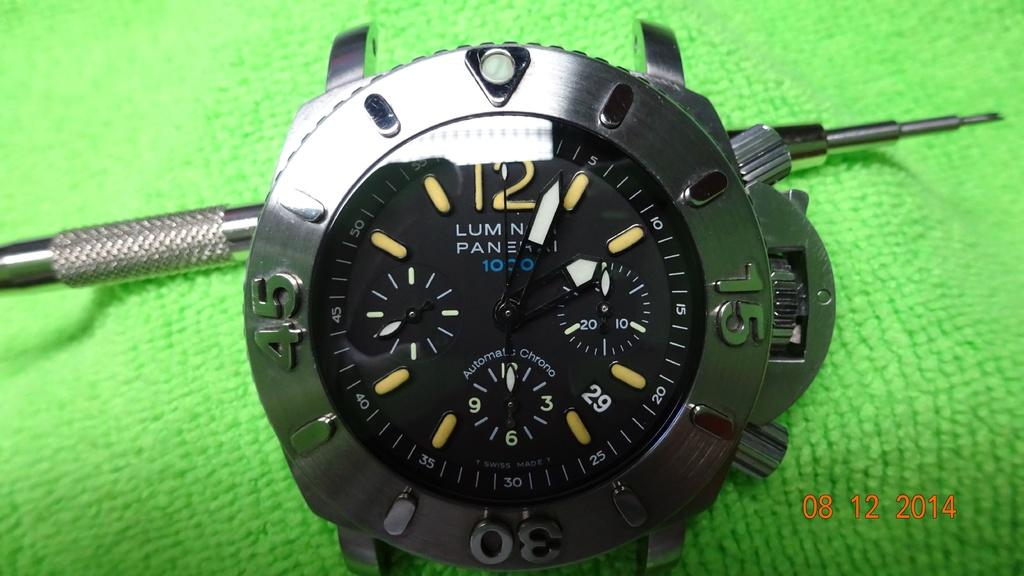<image>
Offer a succinct explanation of the picture presented. Luminar black, white, and blue watch on a green cloth 